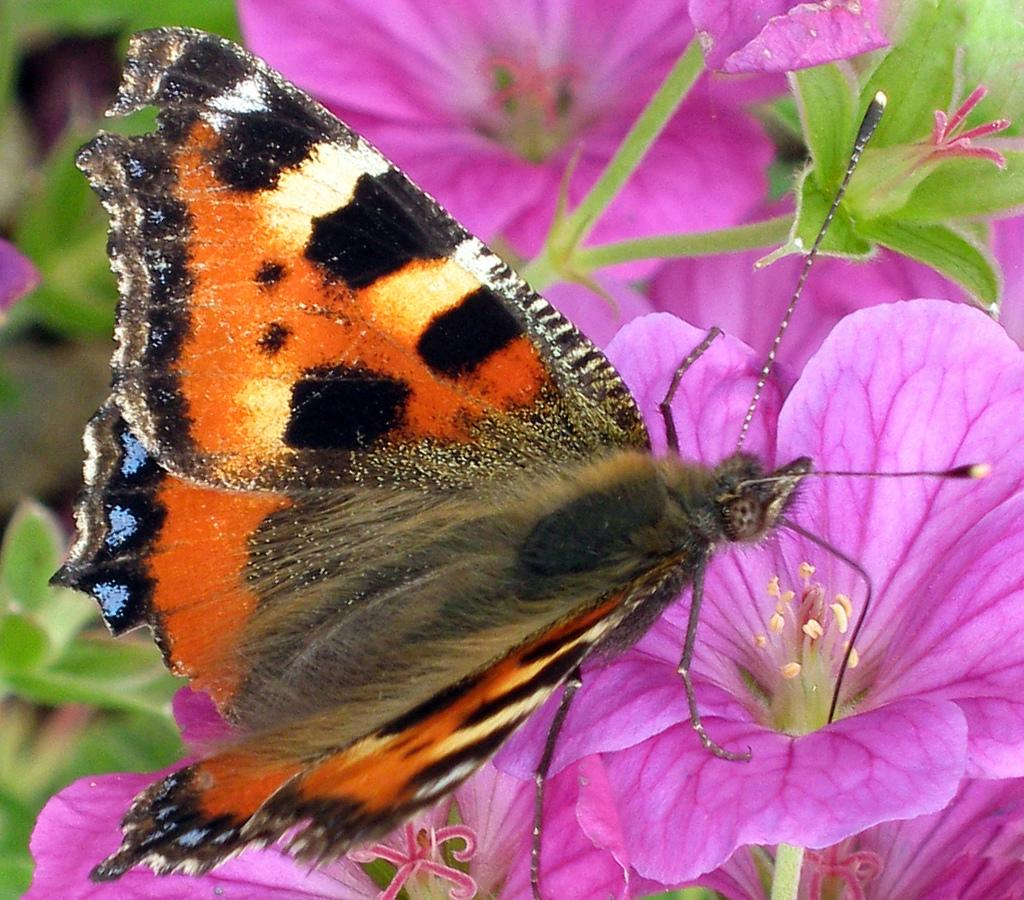What is the main subject of the image? There is a butterfly in the image. Where is the butterfly located? The butterfly is on a flower. What else can be seen in the image besides the butterfly? There are flowers visible in the image. Can you describe the background of the image? The background of the image is blurred. What type of competition is taking place between the flowers in the image? There is no competition between the flowers in the image; they are simply visible alongside the butterfly. 